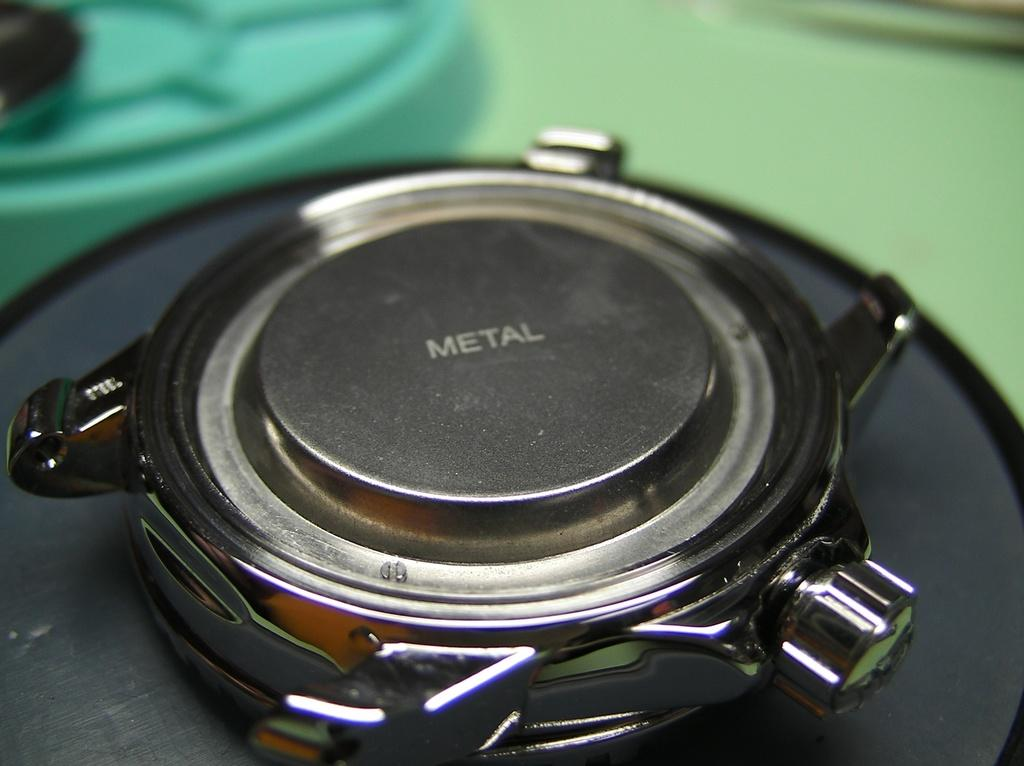<image>
Give a short and clear explanation of the subsequent image. A speaker is facing down on a table and says Metal on the back. 